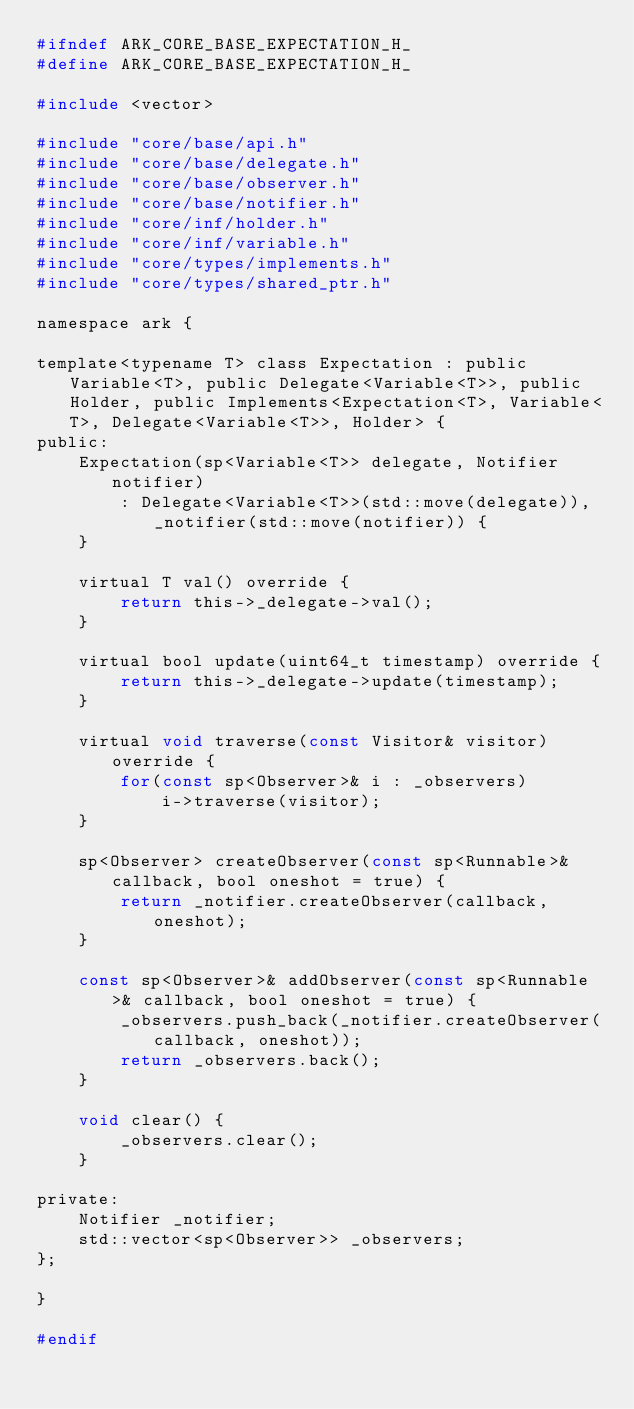<code> <loc_0><loc_0><loc_500><loc_500><_C_>#ifndef ARK_CORE_BASE_EXPECTATION_H_
#define ARK_CORE_BASE_EXPECTATION_H_

#include <vector>

#include "core/base/api.h"
#include "core/base/delegate.h"
#include "core/base/observer.h"
#include "core/base/notifier.h"
#include "core/inf/holder.h"
#include "core/inf/variable.h"
#include "core/types/implements.h"
#include "core/types/shared_ptr.h"

namespace ark {

template<typename T> class Expectation : public Variable<T>, public Delegate<Variable<T>>, public Holder, public Implements<Expectation<T>, Variable<T>, Delegate<Variable<T>>, Holder> {
public:
    Expectation(sp<Variable<T>> delegate, Notifier notifier)
        : Delegate<Variable<T>>(std::move(delegate)), _notifier(std::move(notifier)) {
    }

    virtual T val() override {
        return this->_delegate->val();
    }

    virtual bool update(uint64_t timestamp) override {
        return this->_delegate->update(timestamp);
    }

    virtual void traverse(const Visitor& visitor) override {
        for(const sp<Observer>& i : _observers)
            i->traverse(visitor);
    }

    sp<Observer> createObserver(const sp<Runnable>& callback, bool oneshot = true) {
        return _notifier.createObserver(callback, oneshot);
    }

    const sp<Observer>& addObserver(const sp<Runnable>& callback, bool oneshot = true) {
        _observers.push_back(_notifier.createObserver(callback, oneshot));
        return _observers.back();
    }

    void clear() {
        _observers.clear();
    }

private:
    Notifier _notifier;
    std::vector<sp<Observer>> _observers;
};

}

#endif
</code> 